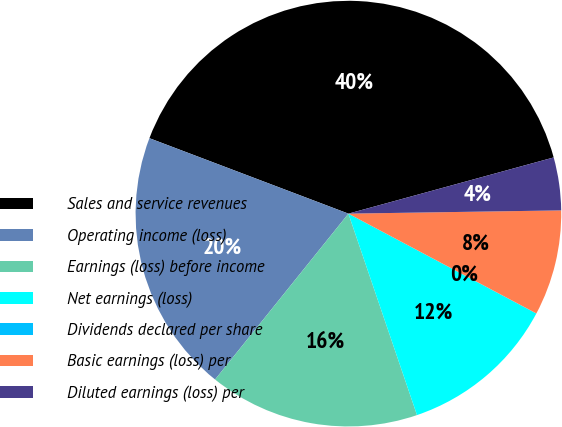Convert chart. <chart><loc_0><loc_0><loc_500><loc_500><pie_chart><fcel>Sales and service revenues<fcel>Operating income (loss)<fcel>Earnings (loss) before income<fcel>Net earnings (loss)<fcel>Dividends declared per share<fcel>Basic earnings (loss) per<fcel>Diluted earnings (loss) per<nl><fcel>39.98%<fcel>19.99%<fcel>16.0%<fcel>12.0%<fcel>0.01%<fcel>8.01%<fcel>4.01%<nl></chart> 